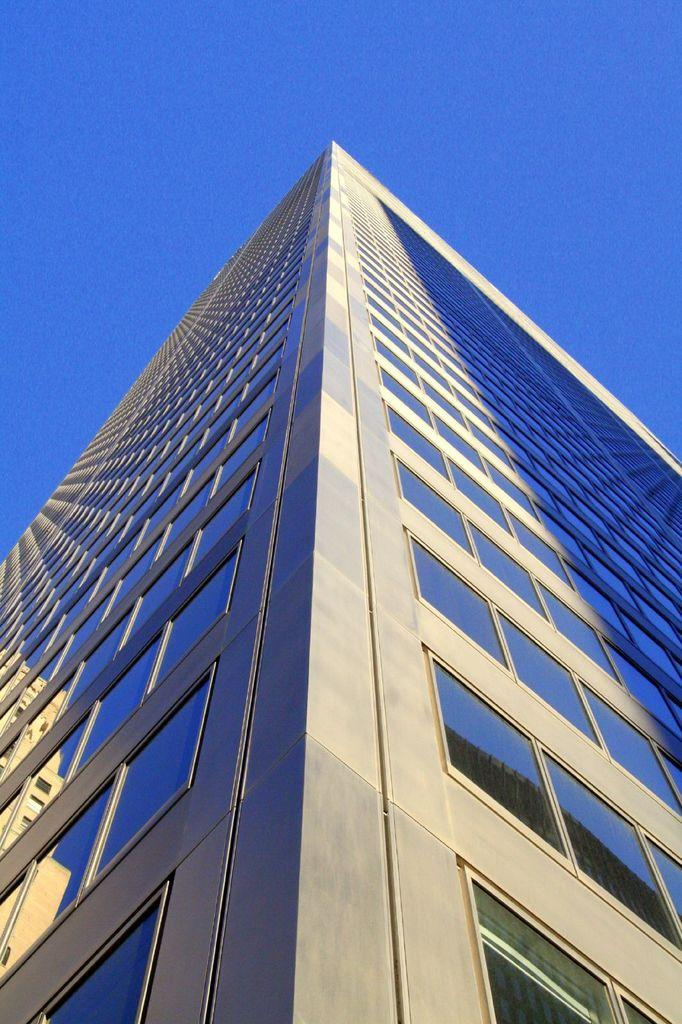What type of structure is visible in the image? There is a building in the image. What feature can be observed on the building? The building has glass windows. What is the condition of the sky in the image? The sky is clear in the image. Can you tell me how many pots of flowers are on the wire in the image? There is no wire or pots of flowers present in the image; it features a building with glass windows and a clear sky. 